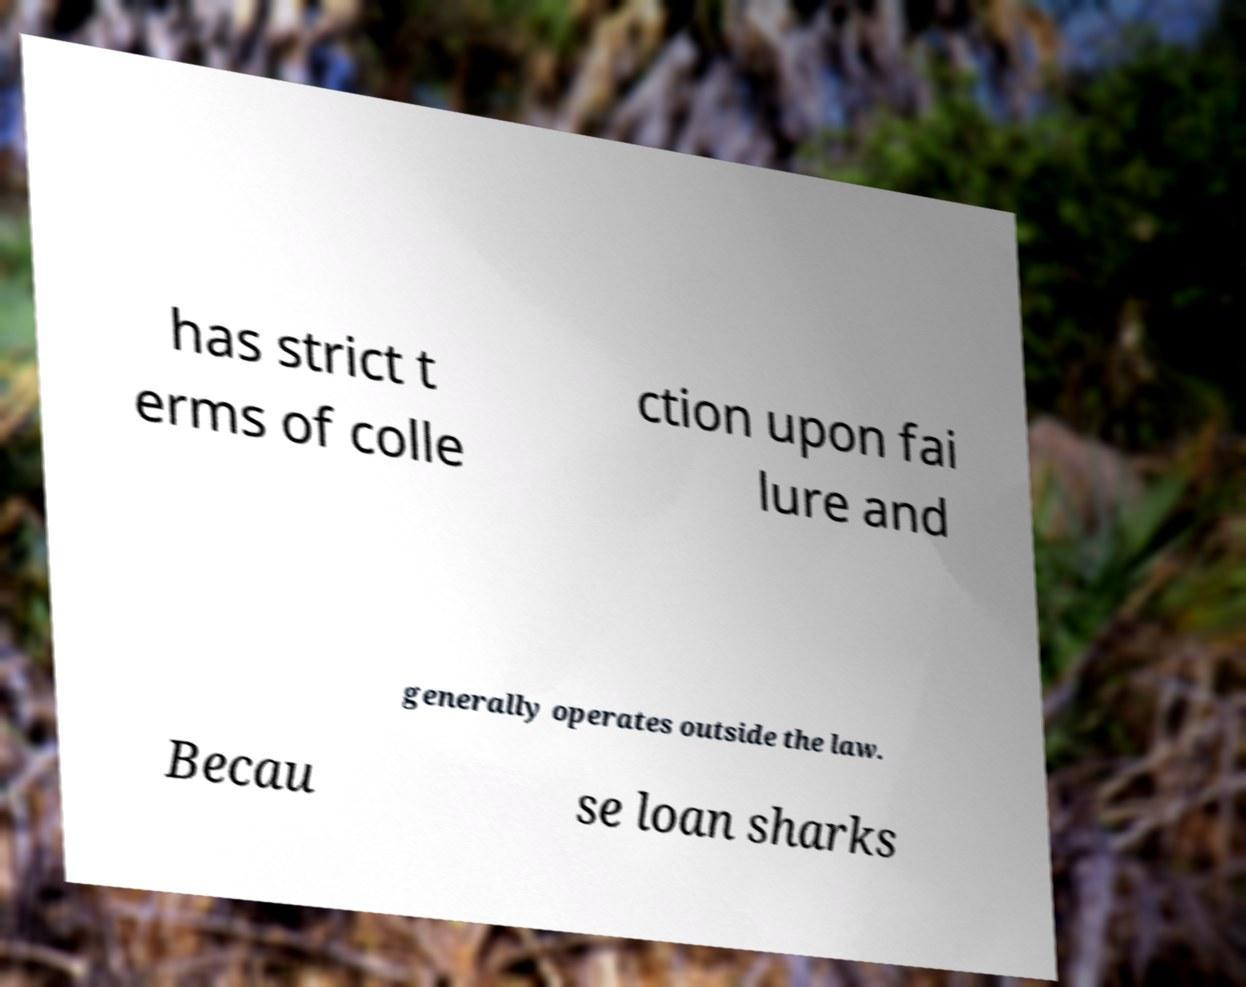Could you assist in decoding the text presented in this image and type it out clearly? has strict t erms of colle ction upon fai lure and generally operates outside the law. Becau se loan sharks 